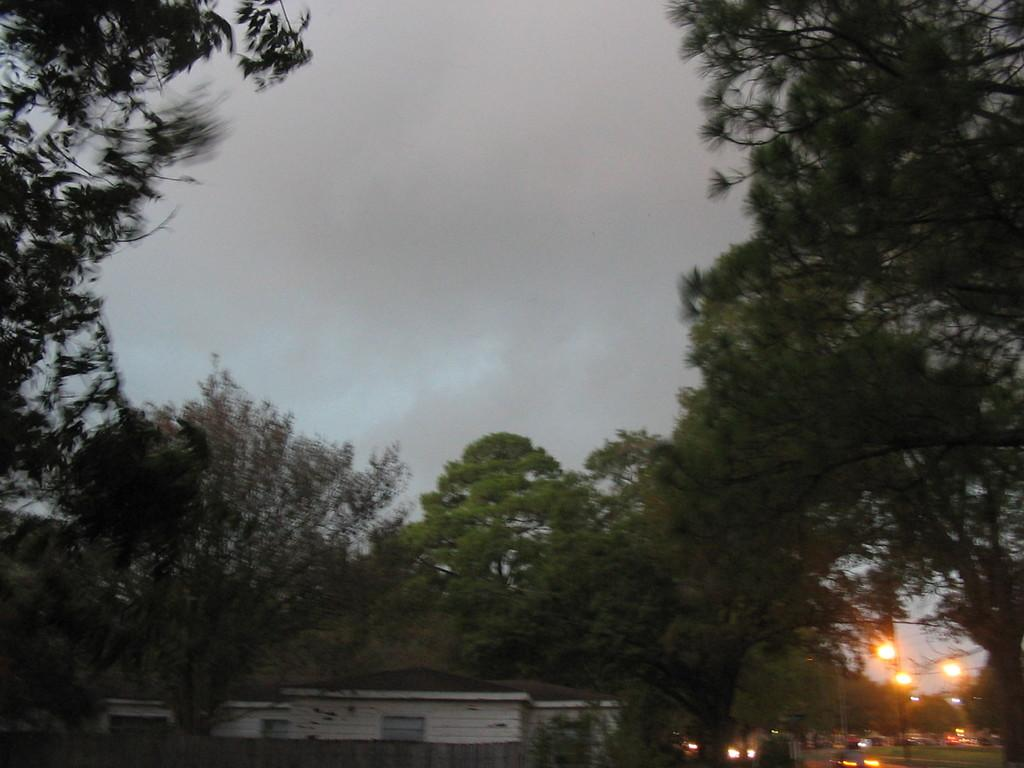What type of structures can be seen on the right side of the image? There are street lights and vehicles on the right side of the image. What type of vegetation is on the left side of the image? There are trees on the left side of the image. What is located in the center of the image? There is a building in the center of the image. Are there any trees in the center of the image? Yes, there are trees present in the center of the image. What is the condition of the sky in the image? The sky is cloudy in the image. What type of disease is depicted in the image? There is no disease depicted in the image; it features street lights, vehicles, trees, a building, and a cloudy sky. What type of station is shown in the image? There is no station present in the image; it features street lights, vehicles, trees, a building, and a cloudy sky. 